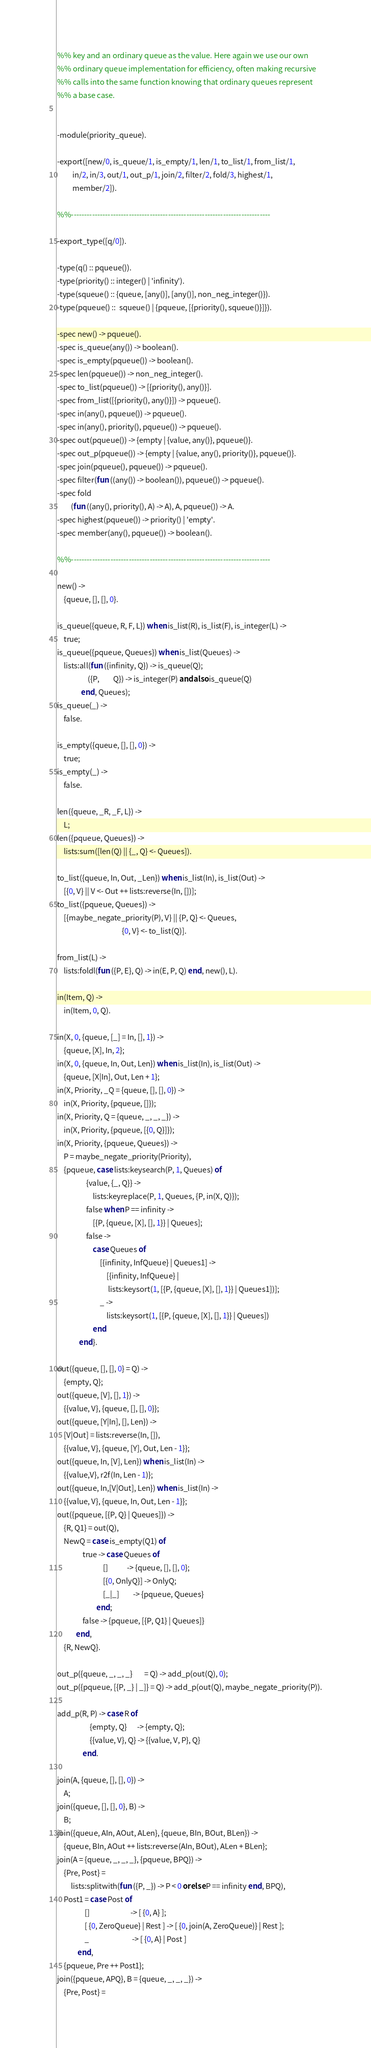Convert code to text. <code><loc_0><loc_0><loc_500><loc_500><_Erlang_>%% key and an ordinary queue as the value. Here again we use our own
%% ordinary queue implementation for efficiency, often making recursive
%% calls into the same function knowing that ordinary queues represent
%% a base case.


-module(priority_queue).

-export([new/0, is_queue/1, is_empty/1, len/1, to_list/1, from_list/1,
         in/2, in/3, out/1, out_p/1, join/2, filter/2, fold/3, highest/1,
         member/2]).

%%----------------------------------------------------------------------------

-export_type([q/0]).

-type(q() :: pqueue()).
-type(priority() :: integer() | 'infinity').
-type(squeue() :: {queue, [any()], [any()], non_neg_integer()}).
-type(pqueue() ::  squeue() | {pqueue, [{priority(), squeue()}]}).

-spec new() -> pqueue().
-spec is_queue(any()) -> boolean().
-spec is_empty(pqueue()) -> boolean().
-spec len(pqueue()) -> non_neg_integer().
-spec to_list(pqueue()) -> [{priority(), any()}].
-spec from_list([{priority(), any()}]) -> pqueue().
-spec in(any(), pqueue()) -> pqueue().
-spec in(any(), priority(), pqueue()) -> pqueue().
-spec out(pqueue()) -> {empty | {value, any()}, pqueue()}.
-spec out_p(pqueue()) -> {empty | {value, any(), priority()}, pqueue()}.
-spec join(pqueue(), pqueue()) -> pqueue().
-spec filter(fun ((any()) -> boolean()), pqueue()) -> pqueue().
-spec fold
        (fun ((any(), priority(), A) -> A), A, pqueue()) -> A.
-spec highest(pqueue()) -> priority() | 'empty'.
-spec member(any(), pqueue()) -> boolean().

%%----------------------------------------------------------------------------

new() ->
    {queue, [], [], 0}.

is_queue({queue, R, F, L}) when is_list(R), is_list(F), is_integer(L) ->
    true;
is_queue({pqueue, Queues}) when is_list(Queues) ->
    lists:all(fun ({infinity, Q}) -> is_queue(Q);
                  ({P,        Q}) -> is_integer(P) andalso is_queue(Q)
              end, Queues);
is_queue(_) ->
    false.

is_empty({queue, [], [], 0}) ->
    true;
is_empty(_) ->
    false.

len({queue, _R, _F, L}) ->
    L;
len({pqueue, Queues}) ->
    lists:sum([len(Q) || {_, Q} <- Queues]).

to_list({queue, In, Out, _Len}) when is_list(In), is_list(Out) ->
    [{0, V} || V <- Out ++ lists:reverse(In, [])];
to_list({pqueue, Queues}) ->
    [{maybe_negate_priority(P), V} || {P, Q} <- Queues,
                                      {0, V} <- to_list(Q)].

from_list(L) ->
    lists:foldl(fun ({P, E}, Q) -> in(E, P, Q) end, new(), L).

in(Item, Q) ->
    in(Item, 0, Q).

in(X, 0, {queue, [_] = In, [], 1}) ->
    {queue, [X], In, 2};
in(X, 0, {queue, In, Out, Len}) when is_list(In), is_list(Out) ->
    {queue, [X|In], Out, Len + 1};
in(X, Priority, _Q = {queue, [], [], 0}) ->
    in(X, Priority, {pqueue, []});
in(X, Priority, Q = {queue, _, _, _}) ->
    in(X, Priority, {pqueue, [{0, Q}]});
in(X, Priority, {pqueue, Queues}) ->
    P = maybe_negate_priority(Priority),
    {pqueue, case lists:keysearch(P, 1, Queues) of
                 {value, {_, Q}} ->
                     lists:keyreplace(P, 1, Queues, {P, in(X, Q)});
                 false when P == infinity ->
                     [{P, {queue, [X], [], 1}} | Queues];
                 false ->
                     case Queues of
                         [{infinity, InfQueue} | Queues1] ->
                             [{infinity, InfQueue} |
                              lists:keysort(1, [{P, {queue, [X], [], 1}} | Queues1])];
                         _ ->
                             lists:keysort(1, [{P, {queue, [X], [], 1}} | Queues])
                     end
             end}.

out({queue, [], [], 0} = Q) ->
    {empty, Q};
out({queue, [V], [], 1}) ->
    {{value, V}, {queue, [], [], 0}};
out({queue, [Y|In], [], Len}) ->
    [V|Out] = lists:reverse(In, []),
    {{value, V}, {queue, [Y], Out, Len - 1}};
out({queue, In, [V], Len}) when is_list(In) ->
    {{value,V}, r2f(In, Len - 1)};
out({queue, In,[V|Out], Len}) when is_list(In) ->
    {{value, V}, {queue, In, Out, Len - 1}};
out({pqueue, [{P, Q} | Queues]}) ->
    {R, Q1} = out(Q),
    NewQ = case is_empty(Q1) of
               true -> case Queues of
                           []           -> {queue, [], [], 0};
                           [{0, OnlyQ}] -> OnlyQ;
                           [_|_]        -> {pqueue, Queues}
                       end;
               false -> {pqueue, [{P, Q1} | Queues]}
           end,
    {R, NewQ}.

out_p({queue, _, _, _}       = Q) -> add_p(out(Q), 0);
out_p({pqueue, [{P, _} | _]} = Q) -> add_p(out(Q), maybe_negate_priority(P)).

add_p(R, P) -> case R of
                   {empty, Q}      -> {empty, Q};
                   {{value, V}, Q} -> {{value, V, P}, Q}
               end.

join(A, {queue, [], [], 0}) ->
    A;
join({queue, [], [], 0}, B) ->
    B;
join({queue, AIn, AOut, ALen}, {queue, BIn, BOut, BLen}) ->
    {queue, BIn, AOut ++ lists:reverse(AIn, BOut), ALen + BLen};
join(A = {queue, _, _, _}, {pqueue, BPQ}) ->
    {Pre, Post} =
        lists:splitwith(fun ({P, _}) -> P < 0 orelse P == infinity end, BPQ),
    Post1 = case Post of
                []                        -> [ {0, A} ];
                [ {0, ZeroQueue} | Rest ] -> [ {0, join(A, ZeroQueue)} | Rest ];
                _                         -> [ {0, A} | Post ]
            end,
    {pqueue, Pre ++ Post1};
join({pqueue, APQ}, B = {queue, _, _, _}) ->
    {Pre, Post} =</code> 